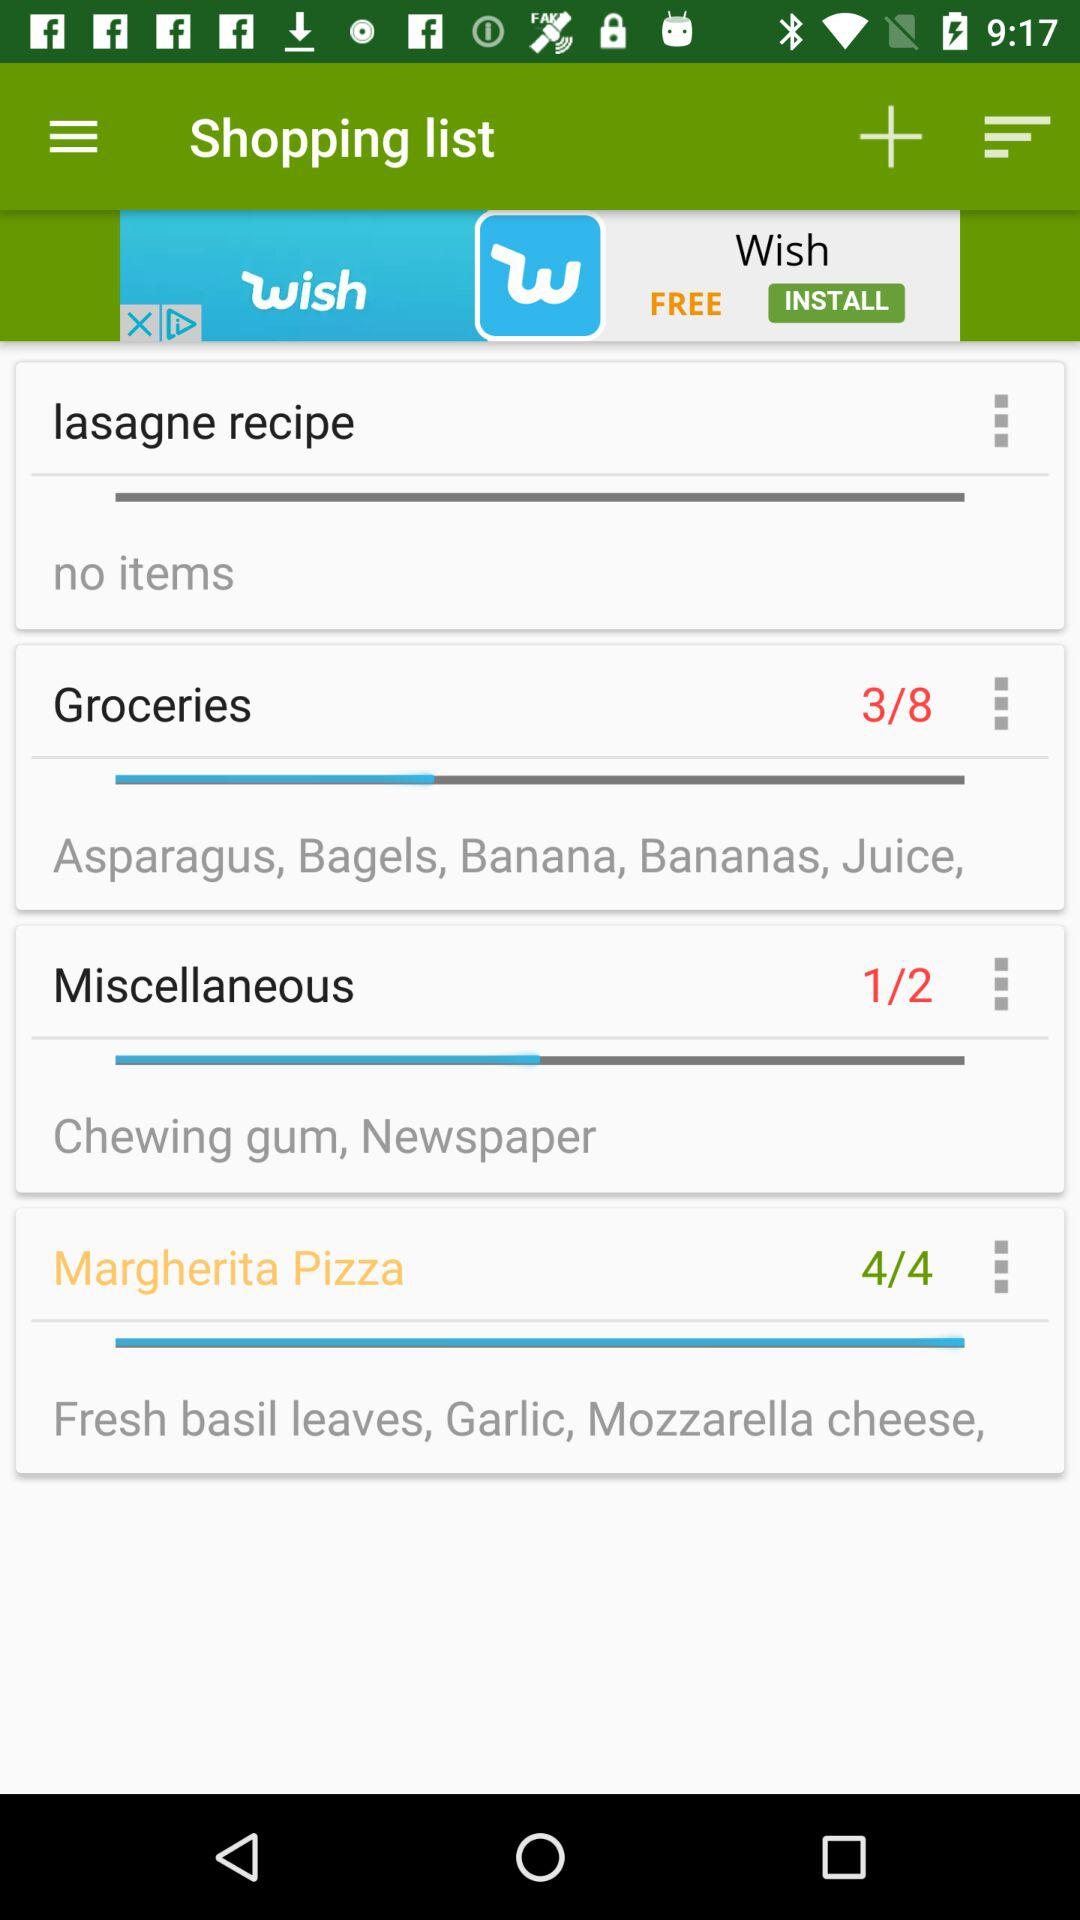Out of eight, how many items have been selected for groceries? Out of eight, 3 items have been selected for groceries. 